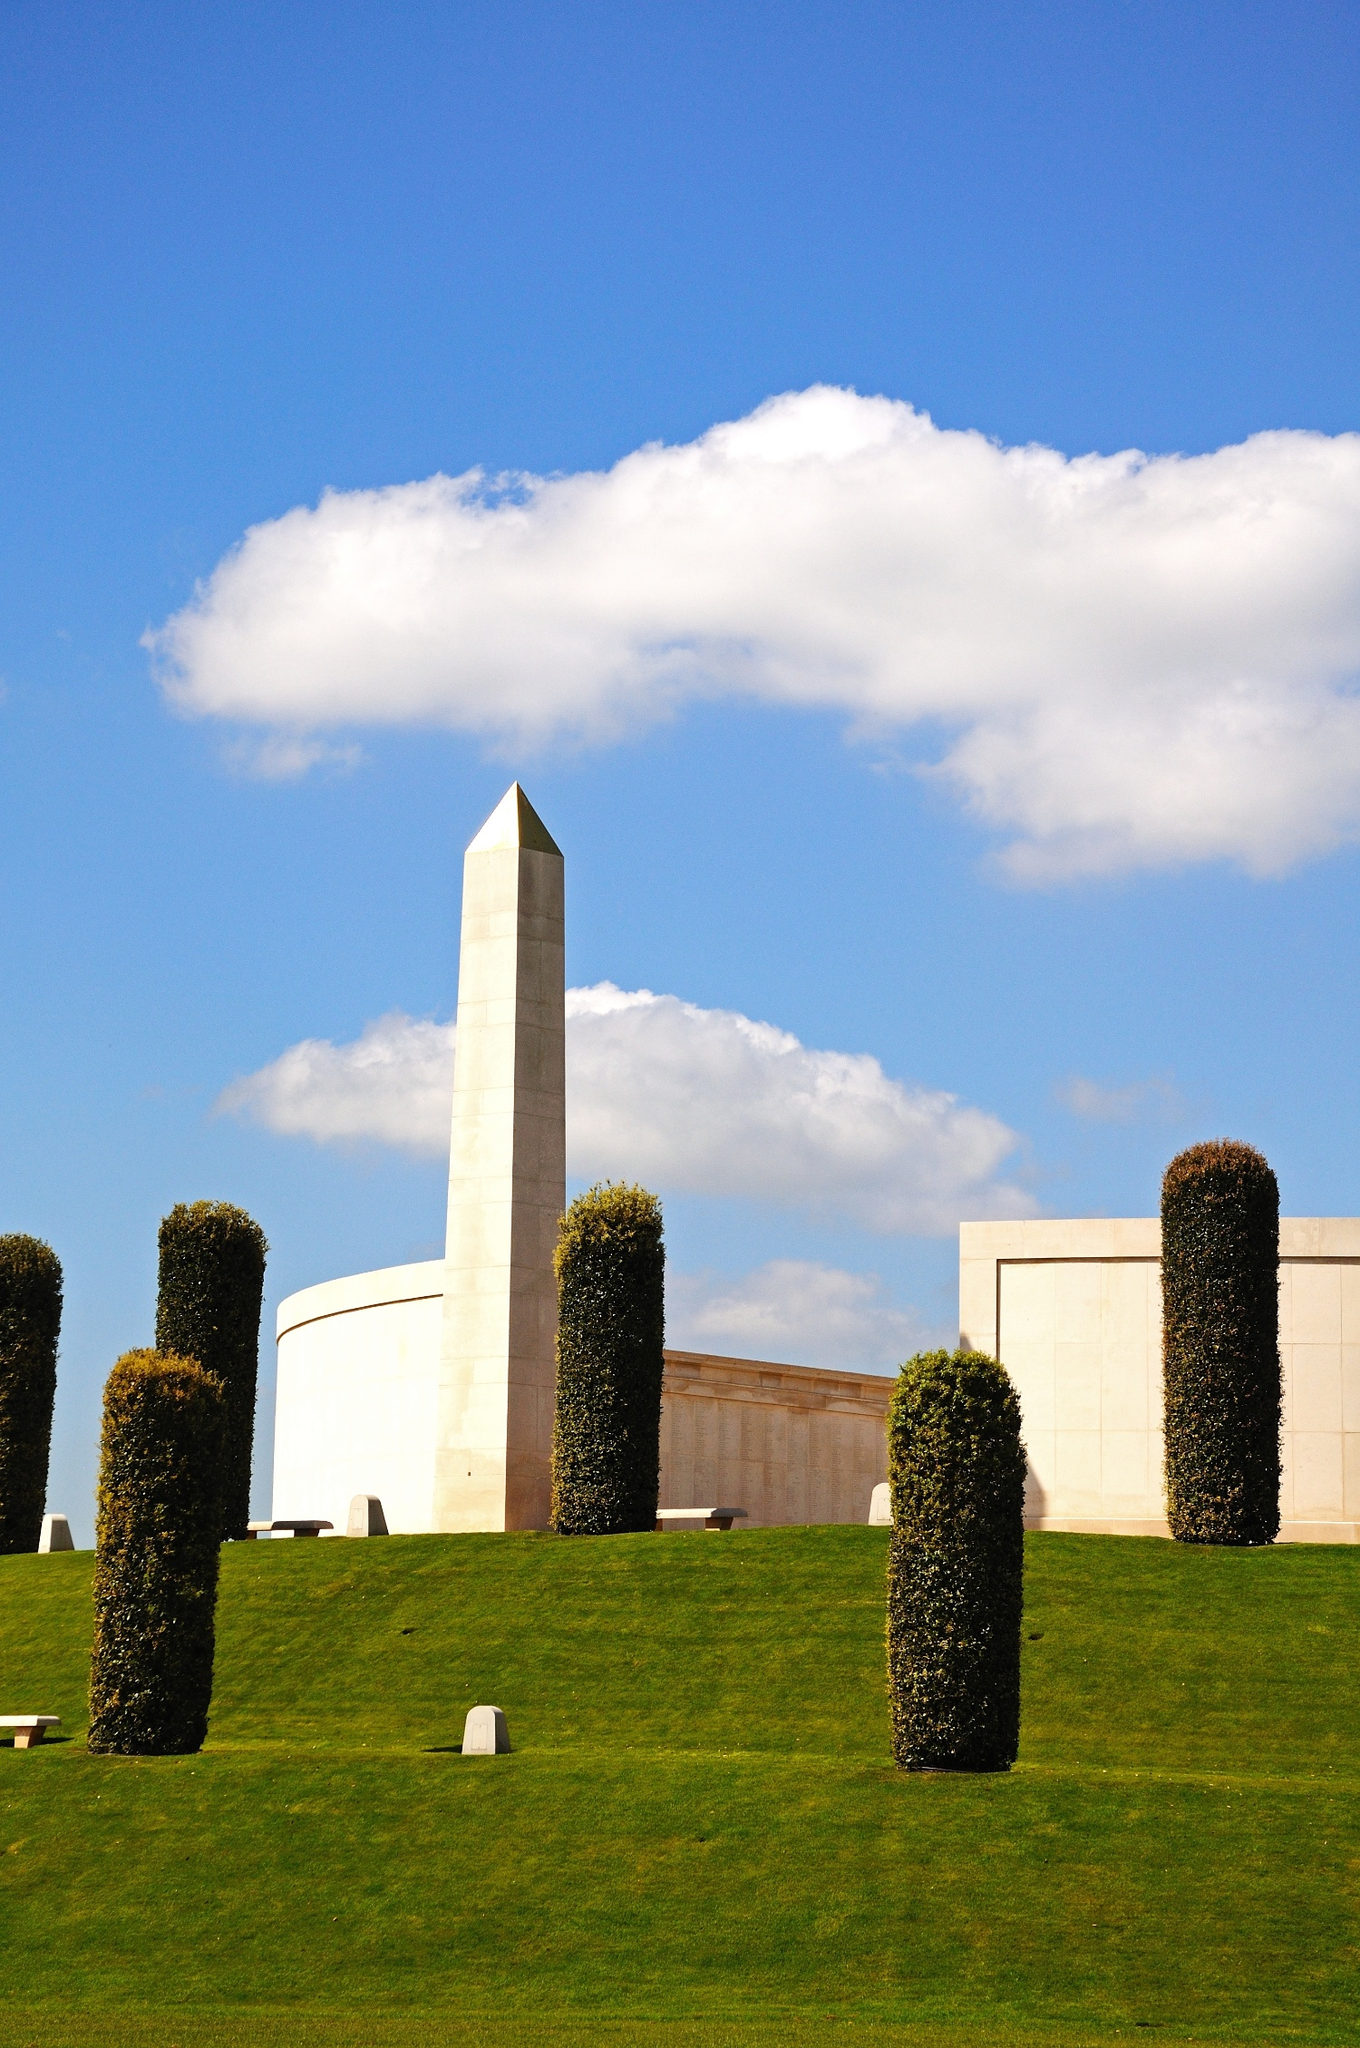Describe the emotional impact that the National Memorial Arboretum might have on its visitors. Visitors to the National Memorial Arboretum often experience a profound sense of solemnity and reverence. The serene landscape, filled with meticulously cared-for memorials and natural beauty, provides a tranquil space for reflection. The sight of the white stone obelisk against a clear blue sky evokes feelings of respect and gratitude for those who have served and sacrificed. The peaceful atmosphere and the significance of the memorials often bring a sense of connection to history, prompting visitors to contemplate the costs of conflict and the value of peace. The arboretum’s carefully designed spaces foster an environment where visitors can honor the memories of the fallen, experience collective mourning, and find solace in the beauty of nature. 